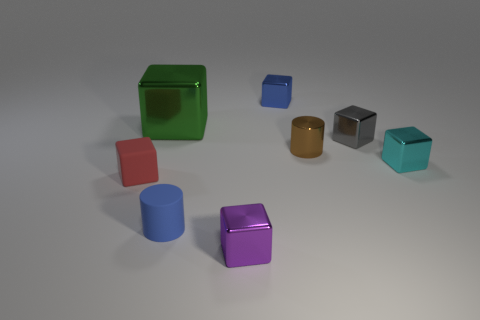Subtract all gray blocks. How many blocks are left? 5 Subtract all purple blocks. How many blocks are left? 5 Subtract all red blocks. Subtract all blue spheres. How many blocks are left? 5 Add 1 tiny purple metallic blocks. How many objects exist? 9 Subtract all cylinders. How many objects are left? 6 Subtract all small cyan metallic things. Subtract all shiny objects. How many objects are left? 1 Add 5 rubber blocks. How many rubber blocks are left? 6 Add 8 tiny blue things. How many tiny blue things exist? 10 Subtract 0 green spheres. How many objects are left? 8 